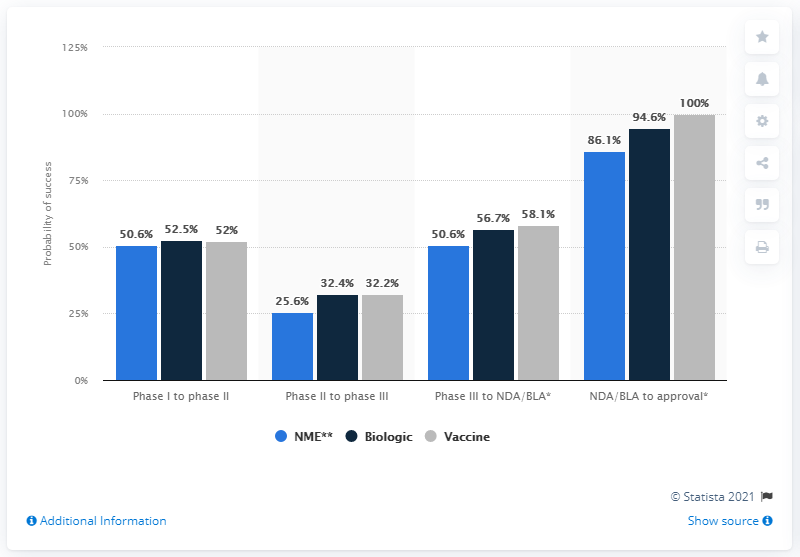List a handful of essential elements in this visual. The average of the percentage change from Phase I to Phase II is 51.7%. It is possible to achieve 100% success in obtaining approval for a vaccine product through the NDA/BLA process. 